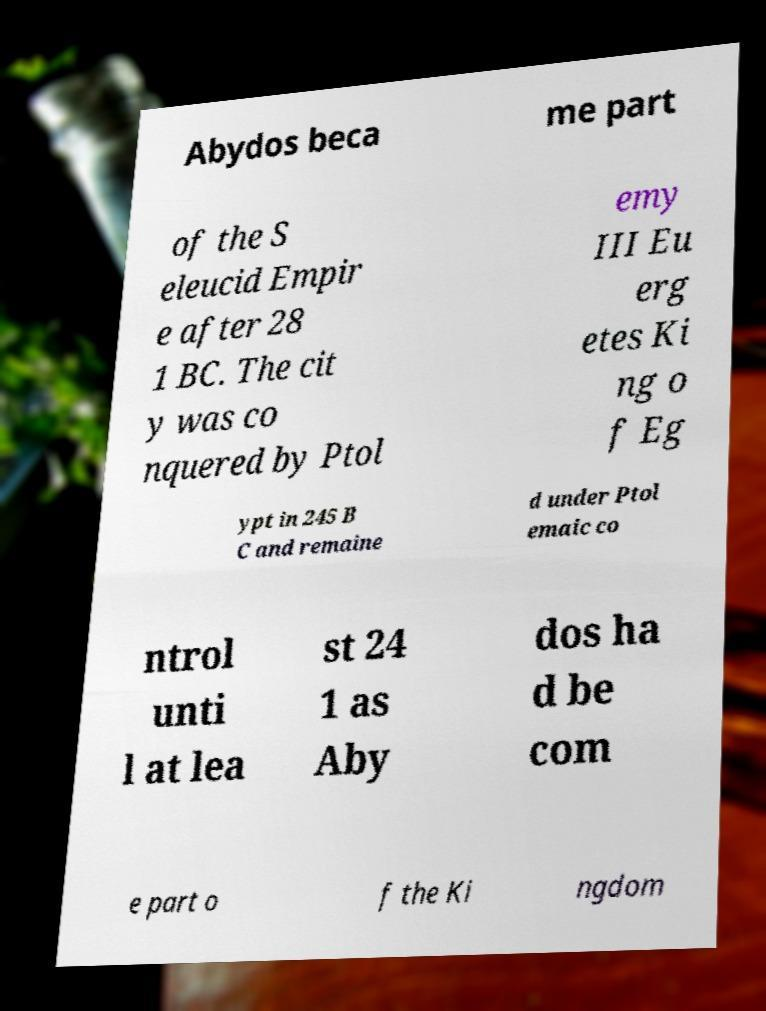Please read and relay the text visible in this image. What does it say? Abydos beca me part of the S eleucid Empir e after 28 1 BC. The cit y was co nquered by Ptol emy III Eu erg etes Ki ng o f Eg ypt in 245 B C and remaine d under Ptol emaic co ntrol unti l at lea st 24 1 as Aby dos ha d be com e part o f the Ki ngdom 